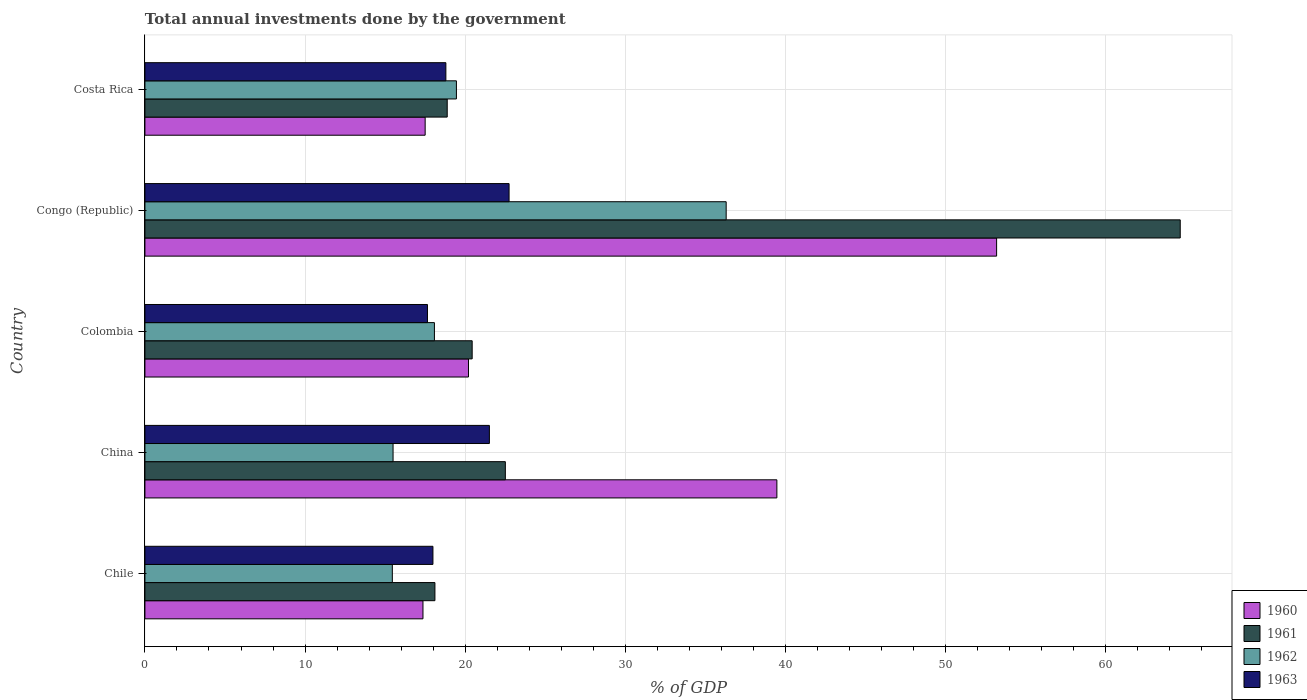Are the number of bars on each tick of the Y-axis equal?
Offer a terse response. Yes. How many bars are there on the 5th tick from the top?
Your answer should be compact. 4. What is the label of the 2nd group of bars from the top?
Keep it short and to the point. Congo (Republic). In how many cases, is the number of bars for a given country not equal to the number of legend labels?
Keep it short and to the point. 0. What is the total annual investments done by the government in 1963 in Colombia?
Provide a short and direct response. 17.64. Across all countries, what is the maximum total annual investments done by the government in 1960?
Offer a terse response. 53.19. Across all countries, what is the minimum total annual investments done by the government in 1963?
Provide a short and direct response. 17.64. In which country was the total annual investments done by the government in 1961 maximum?
Your answer should be compact. Congo (Republic). In which country was the total annual investments done by the government in 1961 minimum?
Provide a succinct answer. Chile. What is the total total annual investments done by the government in 1960 in the graph?
Offer a terse response. 147.72. What is the difference between the total annual investments done by the government in 1962 in Chile and that in China?
Provide a short and direct response. -0.05. What is the difference between the total annual investments done by the government in 1960 in Chile and the total annual investments done by the government in 1961 in Congo (Republic)?
Offer a terse response. -47.29. What is the average total annual investments done by the government in 1961 per country?
Give a very brief answer. 28.92. What is the difference between the total annual investments done by the government in 1962 and total annual investments done by the government in 1960 in Chile?
Ensure brevity in your answer.  -1.91. In how many countries, is the total annual investments done by the government in 1963 greater than 62 %?
Make the answer very short. 0. What is the ratio of the total annual investments done by the government in 1962 in Chile to that in China?
Give a very brief answer. 1. Is the total annual investments done by the government in 1960 in Chile less than that in Costa Rica?
Make the answer very short. Yes. What is the difference between the highest and the second highest total annual investments done by the government in 1960?
Provide a short and direct response. 13.72. What is the difference between the highest and the lowest total annual investments done by the government in 1963?
Offer a very short reply. 5.1. What does the 3rd bar from the top in Chile represents?
Ensure brevity in your answer.  1961. What does the 2nd bar from the bottom in Chile represents?
Your answer should be very brief. 1961. Are all the bars in the graph horizontal?
Your answer should be compact. Yes. What is the difference between two consecutive major ticks on the X-axis?
Make the answer very short. 10. How are the legend labels stacked?
Make the answer very short. Vertical. What is the title of the graph?
Offer a terse response. Total annual investments done by the government. What is the label or title of the X-axis?
Keep it short and to the point. % of GDP. What is the label or title of the Y-axis?
Provide a short and direct response. Country. What is the % of GDP of 1960 in Chile?
Your answer should be compact. 17.36. What is the % of GDP in 1961 in Chile?
Your answer should be compact. 18.11. What is the % of GDP of 1962 in Chile?
Your answer should be very brief. 15.45. What is the % of GDP in 1963 in Chile?
Make the answer very short. 17.99. What is the % of GDP in 1960 in China?
Make the answer very short. 39.46. What is the % of GDP in 1961 in China?
Ensure brevity in your answer.  22.51. What is the % of GDP of 1962 in China?
Ensure brevity in your answer.  15.5. What is the % of GDP in 1963 in China?
Your answer should be very brief. 21.51. What is the % of GDP in 1960 in Colombia?
Your answer should be compact. 20.21. What is the % of GDP of 1961 in Colombia?
Provide a short and direct response. 20.44. What is the % of GDP of 1962 in Colombia?
Provide a succinct answer. 18.08. What is the % of GDP in 1963 in Colombia?
Keep it short and to the point. 17.64. What is the % of GDP in 1960 in Congo (Republic)?
Ensure brevity in your answer.  53.19. What is the % of GDP of 1961 in Congo (Republic)?
Offer a very short reply. 64.65. What is the % of GDP of 1962 in Congo (Republic)?
Provide a succinct answer. 36.3. What is the % of GDP of 1963 in Congo (Republic)?
Offer a terse response. 22.74. What is the % of GDP in 1960 in Costa Rica?
Offer a very short reply. 17.5. What is the % of GDP of 1961 in Costa Rica?
Keep it short and to the point. 18.88. What is the % of GDP in 1962 in Costa Rica?
Make the answer very short. 19.45. What is the % of GDP in 1963 in Costa Rica?
Make the answer very short. 18.79. Across all countries, what is the maximum % of GDP in 1960?
Give a very brief answer. 53.19. Across all countries, what is the maximum % of GDP in 1961?
Provide a short and direct response. 64.65. Across all countries, what is the maximum % of GDP of 1962?
Your response must be concise. 36.3. Across all countries, what is the maximum % of GDP in 1963?
Offer a very short reply. 22.74. Across all countries, what is the minimum % of GDP in 1960?
Give a very brief answer. 17.36. Across all countries, what is the minimum % of GDP in 1961?
Your response must be concise. 18.11. Across all countries, what is the minimum % of GDP in 1962?
Give a very brief answer. 15.45. Across all countries, what is the minimum % of GDP in 1963?
Ensure brevity in your answer.  17.64. What is the total % of GDP in 1960 in the graph?
Offer a very short reply. 147.72. What is the total % of GDP in 1961 in the graph?
Your answer should be very brief. 144.59. What is the total % of GDP of 1962 in the graph?
Ensure brevity in your answer.  104.78. What is the total % of GDP of 1963 in the graph?
Your response must be concise. 98.68. What is the difference between the % of GDP of 1960 in Chile and that in China?
Make the answer very short. -22.1. What is the difference between the % of GDP of 1961 in Chile and that in China?
Keep it short and to the point. -4.4. What is the difference between the % of GDP in 1962 in Chile and that in China?
Make the answer very short. -0.05. What is the difference between the % of GDP of 1963 in Chile and that in China?
Your answer should be compact. -3.52. What is the difference between the % of GDP of 1960 in Chile and that in Colombia?
Provide a succinct answer. -2.84. What is the difference between the % of GDP of 1961 in Chile and that in Colombia?
Give a very brief answer. -2.33. What is the difference between the % of GDP of 1962 in Chile and that in Colombia?
Offer a terse response. -2.63. What is the difference between the % of GDP in 1963 in Chile and that in Colombia?
Your response must be concise. 0.34. What is the difference between the % of GDP of 1960 in Chile and that in Congo (Republic)?
Offer a terse response. -35.82. What is the difference between the % of GDP in 1961 in Chile and that in Congo (Republic)?
Provide a short and direct response. -46.54. What is the difference between the % of GDP in 1962 in Chile and that in Congo (Republic)?
Provide a succinct answer. -20.85. What is the difference between the % of GDP of 1963 in Chile and that in Congo (Republic)?
Keep it short and to the point. -4.75. What is the difference between the % of GDP in 1960 in Chile and that in Costa Rica?
Provide a short and direct response. -0.14. What is the difference between the % of GDP of 1961 in Chile and that in Costa Rica?
Ensure brevity in your answer.  -0.77. What is the difference between the % of GDP of 1962 in Chile and that in Costa Rica?
Make the answer very short. -4. What is the difference between the % of GDP of 1963 in Chile and that in Costa Rica?
Your answer should be very brief. -0.81. What is the difference between the % of GDP of 1960 in China and that in Colombia?
Your response must be concise. 19.26. What is the difference between the % of GDP in 1961 in China and that in Colombia?
Give a very brief answer. 2.07. What is the difference between the % of GDP of 1962 in China and that in Colombia?
Offer a very short reply. -2.58. What is the difference between the % of GDP of 1963 in China and that in Colombia?
Offer a very short reply. 3.87. What is the difference between the % of GDP in 1960 in China and that in Congo (Republic)?
Offer a terse response. -13.72. What is the difference between the % of GDP in 1961 in China and that in Congo (Republic)?
Ensure brevity in your answer.  -42.15. What is the difference between the % of GDP in 1962 in China and that in Congo (Republic)?
Give a very brief answer. -20.8. What is the difference between the % of GDP of 1963 in China and that in Congo (Republic)?
Provide a succinct answer. -1.23. What is the difference between the % of GDP of 1960 in China and that in Costa Rica?
Provide a succinct answer. 21.96. What is the difference between the % of GDP in 1961 in China and that in Costa Rica?
Provide a succinct answer. 3.63. What is the difference between the % of GDP of 1962 in China and that in Costa Rica?
Your answer should be compact. -3.96. What is the difference between the % of GDP of 1963 in China and that in Costa Rica?
Offer a terse response. 2.72. What is the difference between the % of GDP of 1960 in Colombia and that in Congo (Republic)?
Ensure brevity in your answer.  -32.98. What is the difference between the % of GDP in 1961 in Colombia and that in Congo (Republic)?
Your response must be concise. -44.22. What is the difference between the % of GDP of 1962 in Colombia and that in Congo (Republic)?
Your answer should be compact. -18.22. What is the difference between the % of GDP of 1963 in Colombia and that in Congo (Republic)?
Offer a very short reply. -5.1. What is the difference between the % of GDP in 1960 in Colombia and that in Costa Rica?
Offer a terse response. 2.71. What is the difference between the % of GDP in 1961 in Colombia and that in Costa Rica?
Offer a very short reply. 1.56. What is the difference between the % of GDP in 1962 in Colombia and that in Costa Rica?
Offer a terse response. -1.37. What is the difference between the % of GDP in 1963 in Colombia and that in Costa Rica?
Offer a very short reply. -1.15. What is the difference between the % of GDP in 1960 in Congo (Republic) and that in Costa Rica?
Offer a very short reply. 35.69. What is the difference between the % of GDP of 1961 in Congo (Republic) and that in Costa Rica?
Offer a very short reply. 45.78. What is the difference between the % of GDP of 1962 in Congo (Republic) and that in Costa Rica?
Ensure brevity in your answer.  16.85. What is the difference between the % of GDP of 1963 in Congo (Republic) and that in Costa Rica?
Offer a very short reply. 3.95. What is the difference between the % of GDP in 1960 in Chile and the % of GDP in 1961 in China?
Your answer should be very brief. -5.14. What is the difference between the % of GDP of 1960 in Chile and the % of GDP of 1962 in China?
Ensure brevity in your answer.  1.87. What is the difference between the % of GDP in 1960 in Chile and the % of GDP in 1963 in China?
Give a very brief answer. -4.15. What is the difference between the % of GDP in 1961 in Chile and the % of GDP in 1962 in China?
Your response must be concise. 2.61. What is the difference between the % of GDP in 1961 in Chile and the % of GDP in 1963 in China?
Keep it short and to the point. -3.4. What is the difference between the % of GDP in 1962 in Chile and the % of GDP in 1963 in China?
Offer a terse response. -6.06. What is the difference between the % of GDP of 1960 in Chile and the % of GDP of 1961 in Colombia?
Ensure brevity in your answer.  -3.07. What is the difference between the % of GDP in 1960 in Chile and the % of GDP in 1962 in Colombia?
Offer a very short reply. -0.72. What is the difference between the % of GDP in 1960 in Chile and the % of GDP in 1963 in Colombia?
Provide a succinct answer. -0.28. What is the difference between the % of GDP in 1961 in Chile and the % of GDP in 1962 in Colombia?
Offer a terse response. 0.03. What is the difference between the % of GDP of 1961 in Chile and the % of GDP of 1963 in Colombia?
Provide a succinct answer. 0.47. What is the difference between the % of GDP of 1962 in Chile and the % of GDP of 1963 in Colombia?
Ensure brevity in your answer.  -2.19. What is the difference between the % of GDP in 1960 in Chile and the % of GDP in 1961 in Congo (Republic)?
Provide a succinct answer. -47.29. What is the difference between the % of GDP in 1960 in Chile and the % of GDP in 1962 in Congo (Republic)?
Make the answer very short. -18.93. What is the difference between the % of GDP of 1960 in Chile and the % of GDP of 1963 in Congo (Republic)?
Make the answer very short. -5.38. What is the difference between the % of GDP in 1961 in Chile and the % of GDP in 1962 in Congo (Republic)?
Make the answer very short. -18.19. What is the difference between the % of GDP of 1961 in Chile and the % of GDP of 1963 in Congo (Republic)?
Ensure brevity in your answer.  -4.63. What is the difference between the % of GDP of 1962 in Chile and the % of GDP of 1963 in Congo (Republic)?
Your answer should be very brief. -7.29. What is the difference between the % of GDP in 1960 in Chile and the % of GDP in 1961 in Costa Rica?
Provide a short and direct response. -1.51. What is the difference between the % of GDP in 1960 in Chile and the % of GDP in 1962 in Costa Rica?
Ensure brevity in your answer.  -2.09. What is the difference between the % of GDP of 1960 in Chile and the % of GDP of 1963 in Costa Rica?
Keep it short and to the point. -1.43. What is the difference between the % of GDP in 1961 in Chile and the % of GDP in 1962 in Costa Rica?
Offer a terse response. -1.34. What is the difference between the % of GDP in 1961 in Chile and the % of GDP in 1963 in Costa Rica?
Give a very brief answer. -0.68. What is the difference between the % of GDP of 1962 in Chile and the % of GDP of 1963 in Costa Rica?
Offer a terse response. -3.34. What is the difference between the % of GDP of 1960 in China and the % of GDP of 1961 in Colombia?
Ensure brevity in your answer.  19.03. What is the difference between the % of GDP of 1960 in China and the % of GDP of 1962 in Colombia?
Provide a short and direct response. 21.39. What is the difference between the % of GDP of 1960 in China and the % of GDP of 1963 in Colombia?
Your answer should be very brief. 21.82. What is the difference between the % of GDP in 1961 in China and the % of GDP in 1962 in Colombia?
Offer a terse response. 4.43. What is the difference between the % of GDP of 1961 in China and the % of GDP of 1963 in Colombia?
Ensure brevity in your answer.  4.86. What is the difference between the % of GDP of 1962 in China and the % of GDP of 1963 in Colombia?
Your answer should be compact. -2.15. What is the difference between the % of GDP of 1960 in China and the % of GDP of 1961 in Congo (Republic)?
Make the answer very short. -25.19. What is the difference between the % of GDP in 1960 in China and the % of GDP in 1962 in Congo (Republic)?
Give a very brief answer. 3.17. What is the difference between the % of GDP in 1960 in China and the % of GDP in 1963 in Congo (Republic)?
Give a very brief answer. 16.72. What is the difference between the % of GDP in 1961 in China and the % of GDP in 1962 in Congo (Republic)?
Provide a short and direct response. -13.79. What is the difference between the % of GDP in 1961 in China and the % of GDP in 1963 in Congo (Republic)?
Provide a succinct answer. -0.23. What is the difference between the % of GDP of 1962 in China and the % of GDP of 1963 in Congo (Republic)?
Provide a short and direct response. -7.24. What is the difference between the % of GDP of 1960 in China and the % of GDP of 1961 in Costa Rica?
Offer a very short reply. 20.59. What is the difference between the % of GDP of 1960 in China and the % of GDP of 1962 in Costa Rica?
Keep it short and to the point. 20.01. What is the difference between the % of GDP of 1960 in China and the % of GDP of 1963 in Costa Rica?
Your answer should be very brief. 20.67. What is the difference between the % of GDP in 1961 in China and the % of GDP in 1962 in Costa Rica?
Provide a short and direct response. 3.05. What is the difference between the % of GDP of 1961 in China and the % of GDP of 1963 in Costa Rica?
Offer a terse response. 3.71. What is the difference between the % of GDP in 1962 in China and the % of GDP in 1963 in Costa Rica?
Offer a terse response. -3.3. What is the difference between the % of GDP in 1960 in Colombia and the % of GDP in 1961 in Congo (Republic)?
Your response must be concise. -44.45. What is the difference between the % of GDP in 1960 in Colombia and the % of GDP in 1962 in Congo (Republic)?
Ensure brevity in your answer.  -16.09. What is the difference between the % of GDP in 1960 in Colombia and the % of GDP in 1963 in Congo (Republic)?
Ensure brevity in your answer.  -2.54. What is the difference between the % of GDP in 1961 in Colombia and the % of GDP in 1962 in Congo (Republic)?
Ensure brevity in your answer.  -15.86. What is the difference between the % of GDP in 1961 in Colombia and the % of GDP in 1963 in Congo (Republic)?
Provide a short and direct response. -2.3. What is the difference between the % of GDP in 1962 in Colombia and the % of GDP in 1963 in Congo (Republic)?
Your answer should be compact. -4.66. What is the difference between the % of GDP of 1960 in Colombia and the % of GDP of 1961 in Costa Rica?
Offer a very short reply. 1.33. What is the difference between the % of GDP in 1960 in Colombia and the % of GDP in 1962 in Costa Rica?
Give a very brief answer. 0.75. What is the difference between the % of GDP of 1960 in Colombia and the % of GDP of 1963 in Costa Rica?
Your answer should be very brief. 1.41. What is the difference between the % of GDP in 1961 in Colombia and the % of GDP in 1962 in Costa Rica?
Your response must be concise. 0.98. What is the difference between the % of GDP in 1961 in Colombia and the % of GDP in 1963 in Costa Rica?
Your response must be concise. 1.64. What is the difference between the % of GDP of 1962 in Colombia and the % of GDP of 1963 in Costa Rica?
Keep it short and to the point. -0.72. What is the difference between the % of GDP in 1960 in Congo (Republic) and the % of GDP in 1961 in Costa Rica?
Ensure brevity in your answer.  34.31. What is the difference between the % of GDP of 1960 in Congo (Republic) and the % of GDP of 1962 in Costa Rica?
Your answer should be compact. 33.73. What is the difference between the % of GDP in 1960 in Congo (Republic) and the % of GDP in 1963 in Costa Rica?
Offer a very short reply. 34.39. What is the difference between the % of GDP of 1961 in Congo (Republic) and the % of GDP of 1962 in Costa Rica?
Provide a short and direct response. 45.2. What is the difference between the % of GDP of 1961 in Congo (Republic) and the % of GDP of 1963 in Costa Rica?
Offer a terse response. 45.86. What is the difference between the % of GDP of 1962 in Congo (Republic) and the % of GDP of 1963 in Costa Rica?
Give a very brief answer. 17.5. What is the average % of GDP of 1960 per country?
Your answer should be compact. 29.54. What is the average % of GDP in 1961 per country?
Ensure brevity in your answer.  28.92. What is the average % of GDP in 1962 per country?
Make the answer very short. 20.96. What is the average % of GDP of 1963 per country?
Your response must be concise. 19.74. What is the difference between the % of GDP in 1960 and % of GDP in 1961 in Chile?
Give a very brief answer. -0.75. What is the difference between the % of GDP in 1960 and % of GDP in 1962 in Chile?
Your answer should be compact. 1.91. What is the difference between the % of GDP of 1960 and % of GDP of 1963 in Chile?
Your answer should be very brief. -0.62. What is the difference between the % of GDP in 1961 and % of GDP in 1962 in Chile?
Provide a short and direct response. 2.66. What is the difference between the % of GDP of 1961 and % of GDP of 1963 in Chile?
Your answer should be very brief. 0.12. What is the difference between the % of GDP of 1962 and % of GDP of 1963 in Chile?
Your answer should be compact. -2.54. What is the difference between the % of GDP of 1960 and % of GDP of 1961 in China?
Make the answer very short. 16.96. What is the difference between the % of GDP of 1960 and % of GDP of 1962 in China?
Your response must be concise. 23.97. What is the difference between the % of GDP of 1960 and % of GDP of 1963 in China?
Offer a terse response. 17.95. What is the difference between the % of GDP in 1961 and % of GDP in 1962 in China?
Your answer should be compact. 7.01. What is the difference between the % of GDP of 1962 and % of GDP of 1963 in China?
Offer a very short reply. -6.01. What is the difference between the % of GDP of 1960 and % of GDP of 1961 in Colombia?
Provide a short and direct response. -0.23. What is the difference between the % of GDP of 1960 and % of GDP of 1962 in Colombia?
Keep it short and to the point. 2.13. What is the difference between the % of GDP in 1960 and % of GDP in 1963 in Colombia?
Provide a short and direct response. 2.56. What is the difference between the % of GDP in 1961 and % of GDP in 1962 in Colombia?
Keep it short and to the point. 2.36. What is the difference between the % of GDP of 1961 and % of GDP of 1963 in Colombia?
Provide a succinct answer. 2.79. What is the difference between the % of GDP of 1962 and % of GDP of 1963 in Colombia?
Ensure brevity in your answer.  0.43. What is the difference between the % of GDP of 1960 and % of GDP of 1961 in Congo (Republic)?
Give a very brief answer. -11.47. What is the difference between the % of GDP in 1960 and % of GDP in 1962 in Congo (Republic)?
Keep it short and to the point. 16.89. What is the difference between the % of GDP of 1960 and % of GDP of 1963 in Congo (Republic)?
Give a very brief answer. 30.45. What is the difference between the % of GDP of 1961 and % of GDP of 1962 in Congo (Republic)?
Your answer should be compact. 28.36. What is the difference between the % of GDP in 1961 and % of GDP in 1963 in Congo (Republic)?
Make the answer very short. 41.91. What is the difference between the % of GDP in 1962 and % of GDP in 1963 in Congo (Republic)?
Provide a succinct answer. 13.56. What is the difference between the % of GDP of 1960 and % of GDP of 1961 in Costa Rica?
Offer a very short reply. -1.38. What is the difference between the % of GDP in 1960 and % of GDP in 1962 in Costa Rica?
Keep it short and to the point. -1.95. What is the difference between the % of GDP of 1960 and % of GDP of 1963 in Costa Rica?
Give a very brief answer. -1.29. What is the difference between the % of GDP in 1961 and % of GDP in 1962 in Costa Rica?
Provide a short and direct response. -0.58. What is the difference between the % of GDP in 1961 and % of GDP in 1963 in Costa Rica?
Provide a short and direct response. 0.08. What is the difference between the % of GDP of 1962 and % of GDP of 1963 in Costa Rica?
Keep it short and to the point. 0.66. What is the ratio of the % of GDP in 1960 in Chile to that in China?
Your response must be concise. 0.44. What is the ratio of the % of GDP of 1961 in Chile to that in China?
Offer a terse response. 0.8. What is the ratio of the % of GDP in 1963 in Chile to that in China?
Give a very brief answer. 0.84. What is the ratio of the % of GDP of 1960 in Chile to that in Colombia?
Provide a succinct answer. 0.86. What is the ratio of the % of GDP of 1961 in Chile to that in Colombia?
Provide a short and direct response. 0.89. What is the ratio of the % of GDP of 1962 in Chile to that in Colombia?
Keep it short and to the point. 0.85. What is the ratio of the % of GDP of 1963 in Chile to that in Colombia?
Make the answer very short. 1.02. What is the ratio of the % of GDP of 1960 in Chile to that in Congo (Republic)?
Offer a terse response. 0.33. What is the ratio of the % of GDP of 1961 in Chile to that in Congo (Republic)?
Your answer should be compact. 0.28. What is the ratio of the % of GDP in 1962 in Chile to that in Congo (Republic)?
Your response must be concise. 0.43. What is the ratio of the % of GDP of 1963 in Chile to that in Congo (Republic)?
Provide a short and direct response. 0.79. What is the ratio of the % of GDP of 1961 in Chile to that in Costa Rica?
Your answer should be compact. 0.96. What is the ratio of the % of GDP in 1962 in Chile to that in Costa Rica?
Make the answer very short. 0.79. What is the ratio of the % of GDP of 1960 in China to that in Colombia?
Keep it short and to the point. 1.95. What is the ratio of the % of GDP in 1961 in China to that in Colombia?
Give a very brief answer. 1.1. What is the ratio of the % of GDP of 1962 in China to that in Colombia?
Your answer should be compact. 0.86. What is the ratio of the % of GDP of 1963 in China to that in Colombia?
Your answer should be very brief. 1.22. What is the ratio of the % of GDP in 1960 in China to that in Congo (Republic)?
Offer a very short reply. 0.74. What is the ratio of the % of GDP of 1961 in China to that in Congo (Republic)?
Make the answer very short. 0.35. What is the ratio of the % of GDP in 1962 in China to that in Congo (Republic)?
Ensure brevity in your answer.  0.43. What is the ratio of the % of GDP in 1963 in China to that in Congo (Republic)?
Provide a succinct answer. 0.95. What is the ratio of the % of GDP in 1960 in China to that in Costa Rica?
Keep it short and to the point. 2.26. What is the ratio of the % of GDP of 1961 in China to that in Costa Rica?
Offer a very short reply. 1.19. What is the ratio of the % of GDP of 1962 in China to that in Costa Rica?
Your response must be concise. 0.8. What is the ratio of the % of GDP of 1963 in China to that in Costa Rica?
Make the answer very short. 1.14. What is the ratio of the % of GDP in 1960 in Colombia to that in Congo (Republic)?
Keep it short and to the point. 0.38. What is the ratio of the % of GDP of 1961 in Colombia to that in Congo (Republic)?
Offer a very short reply. 0.32. What is the ratio of the % of GDP in 1962 in Colombia to that in Congo (Republic)?
Your answer should be very brief. 0.5. What is the ratio of the % of GDP of 1963 in Colombia to that in Congo (Republic)?
Ensure brevity in your answer.  0.78. What is the ratio of the % of GDP in 1960 in Colombia to that in Costa Rica?
Your answer should be compact. 1.15. What is the ratio of the % of GDP in 1961 in Colombia to that in Costa Rica?
Give a very brief answer. 1.08. What is the ratio of the % of GDP in 1962 in Colombia to that in Costa Rica?
Provide a short and direct response. 0.93. What is the ratio of the % of GDP of 1963 in Colombia to that in Costa Rica?
Make the answer very short. 0.94. What is the ratio of the % of GDP of 1960 in Congo (Republic) to that in Costa Rica?
Offer a terse response. 3.04. What is the ratio of the % of GDP in 1961 in Congo (Republic) to that in Costa Rica?
Ensure brevity in your answer.  3.42. What is the ratio of the % of GDP of 1962 in Congo (Republic) to that in Costa Rica?
Your response must be concise. 1.87. What is the ratio of the % of GDP in 1963 in Congo (Republic) to that in Costa Rica?
Offer a very short reply. 1.21. What is the difference between the highest and the second highest % of GDP in 1960?
Ensure brevity in your answer.  13.72. What is the difference between the highest and the second highest % of GDP in 1961?
Keep it short and to the point. 42.15. What is the difference between the highest and the second highest % of GDP in 1962?
Give a very brief answer. 16.85. What is the difference between the highest and the second highest % of GDP in 1963?
Offer a very short reply. 1.23. What is the difference between the highest and the lowest % of GDP of 1960?
Provide a succinct answer. 35.82. What is the difference between the highest and the lowest % of GDP in 1961?
Offer a terse response. 46.54. What is the difference between the highest and the lowest % of GDP of 1962?
Your response must be concise. 20.85. What is the difference between the highest and the lowest % of GDP in 1963?
Keep it short and to the point. 5.1. 